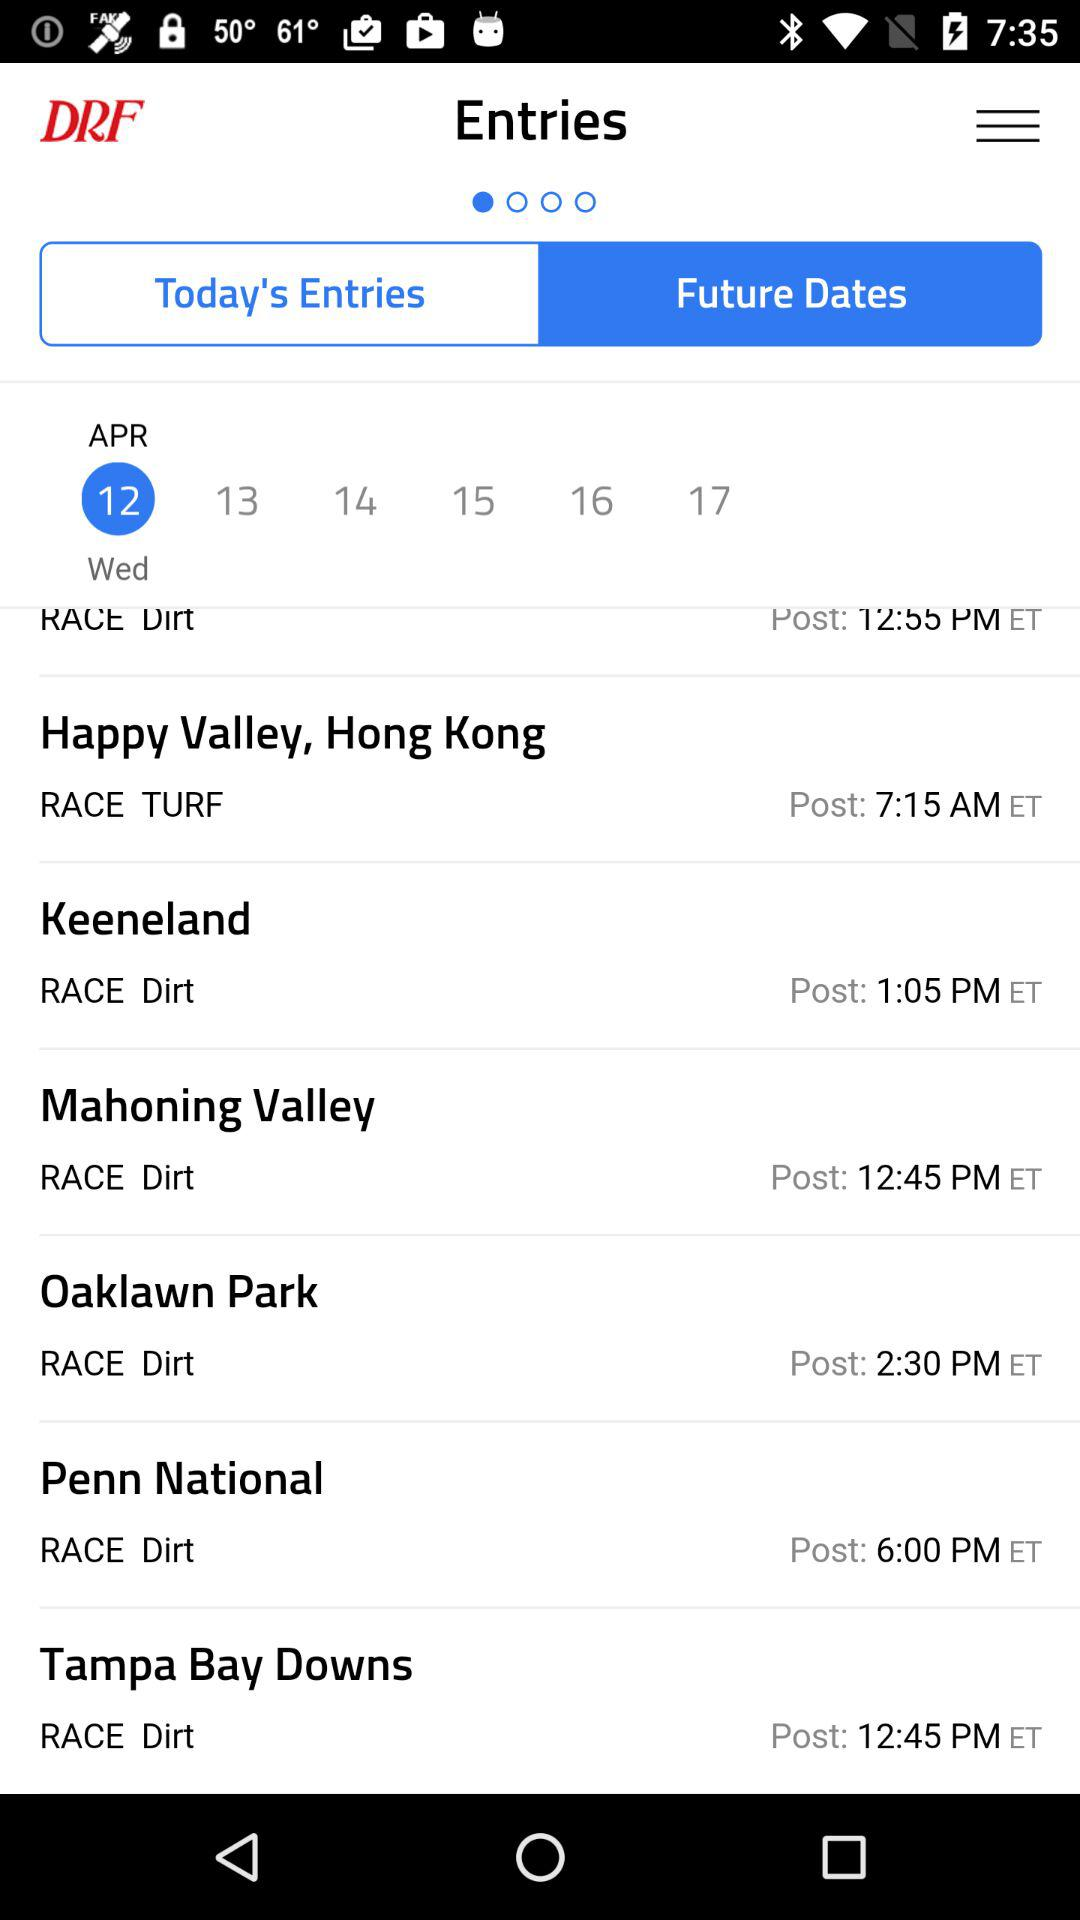What is the time in the "Penn National"? The time is 6:00 PM. 